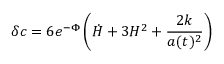Convert formula to latex. <formula><loc_0><loc_0><loc_500><loc_500>\delta c = 6 e ^ { - \Phi } \left ( { \dot { H } } + 3 H ^ { 2 } + \frac { 2 k } { a ( t ) ^ { 2 } } \right )</formula> 